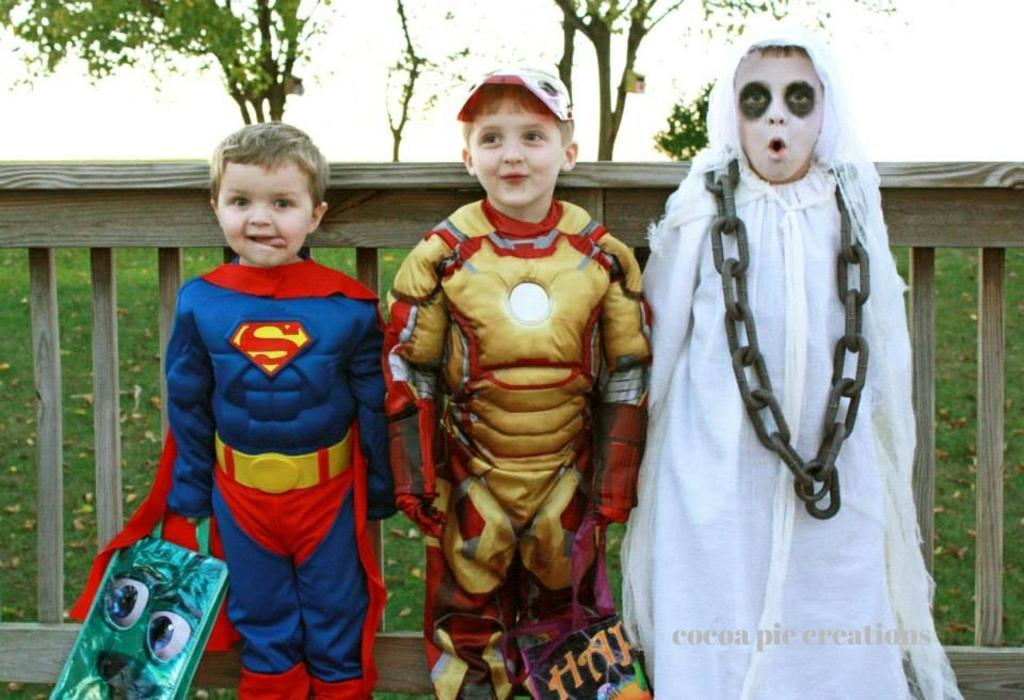How many kids are in the image? There are three kids in the image. What are the kids wearing? The kids are wearing costumes. What can be seen in the background of the image? There is wooden fencing, grassland, and a tree in the background of the image. Is there any text present in the image? Yes, there is text in the bottom right corner of the image. What type of flesh can be seen in the image? There is no flesh present in the image; it features three kids wearing costumes and a background with wooden fencing, grassland, and a tree. What is the lead character in the image doing? There is no lead character mentioned in the facts provided, and the image features three kids without any specific actions being performed. 